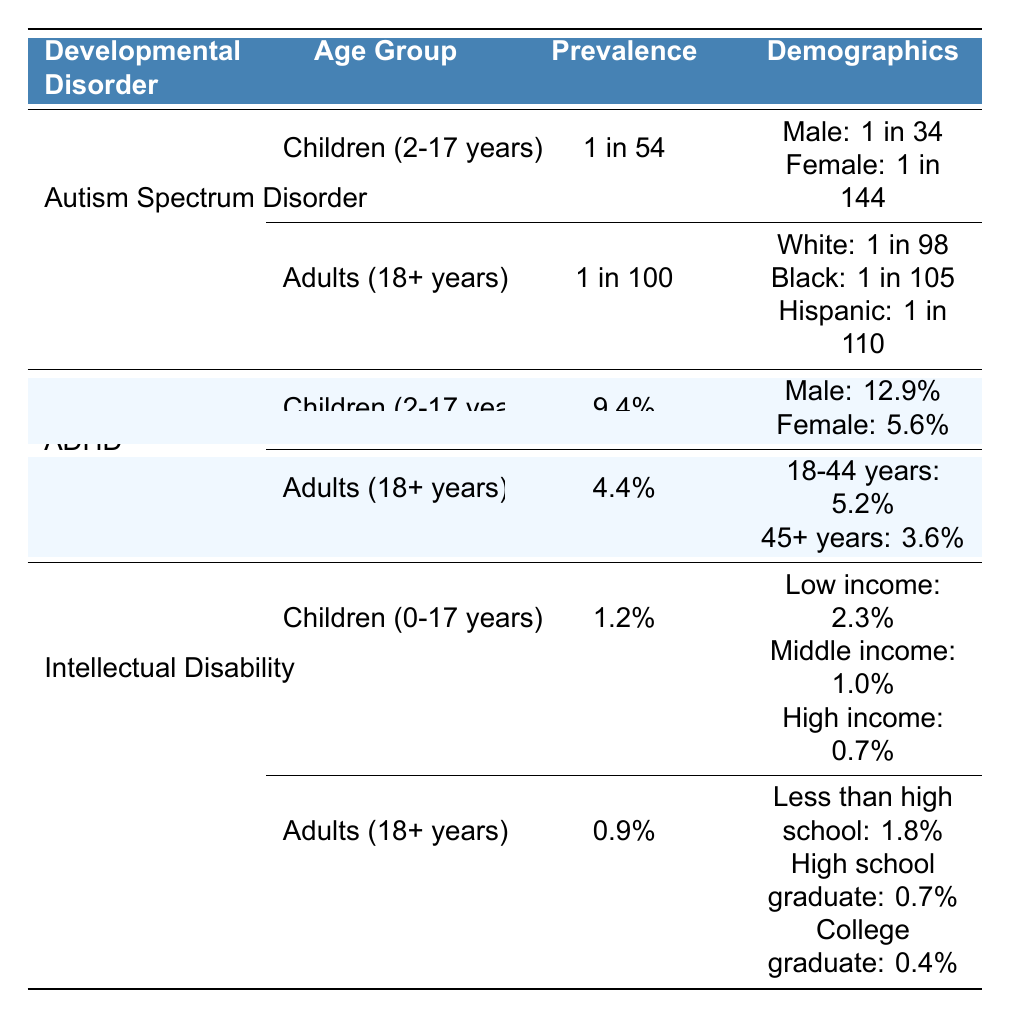What is the prevalence rate of Autism Spectrum Disorder in children aged 2-17 years? The table states that the prevalence of Autism Spectrum Disorder in children (2-17 years) is 1 in 54.
Answer: 1 in 54 What is the prevalence rate of ADHD in adults aged 18 years and older? According to the table, the prevalence of ADHD in adults (18+ years) is 4.4%.
Answer: 4.4% Which gender has a higher prevalence rate of Autism Spectrum Disorder in children? The table shows that the prevalence rate for boys is 1 in 34 and for girls is 1 in 144, indicating that boys have a higher prevalence rate.
Answer: Male What is the prevalence of Intellectual Disability in low-income children? The table indicates that the prevalence of Intellectual Disability among low-income children (0-17 years) is 2.3%.
Answer: 2.3% Is the prevalence of ADHD in females higher than in males among children? The table shows that the prevalence in males is 12.9% while in females it is 5.6%, meaning the prevalence in females is lower.
Answer: No What is the difference in prevalence rates of Autism Spectrum Disorder between males and females in children? For males, the rate is 1 in 34, and for females it's 1 in 144. To find the difference, compare these two rates: 1 in 34 is a higher frequency than 1 in 144, but you can't subtract ratios directly like this. However, considering both are in comparison to the population base, the ratio indicates a greater impact on males.
Answer: Males are more affected What is the prevalence of Intellectual Disability in adults with less than a high school education? The table states that for adults (18+ years) with less than a high school education, the prevalence of Intellectual Disability is 1.8%.
Answer: 1.8% Which ethnic group has the highest prevalence of Autism Spectrum Disorder in adults? The table shows the prevalence rates for adults: White (1 in 98), Black (1 in 105), and Hispanic (1 in 110). White has the highest prevalence rate.
Answer: White What is the average prevalence rate of ADHD in children compared to adults? For children, the prevalence is 9.4%. For adults (both age groups combined), the average is (5.2% + 3.6%) / 2 = 4.4%. Thus, children have a higher average prevalence of 9.4% than adults.
Answer: Higher in children How does the prevalence of Intellectual Disability vary across different income levels in children? The table lists 2.3% for low income, 1.0% for middle income, and 0.7% for high income. Therefore, prevalence decreases from low to high income levels.
Answer: Decreases with income What is the combined prevalence of ADHD in males and females among children? The table states that the prevalence is 12.9% for males and 5.6% for females. To find the combined prevalence for analysis, one must take these quantitative rates into consideration together in context. However, for direct comparison and not arithmetic, males lead significantly over females as shown in their respective rates.
Answer: Higher in males 